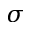Convert formula to latex. <formula><loc_0><loc_0><loc_500><loc_500>\sigma</formula> 